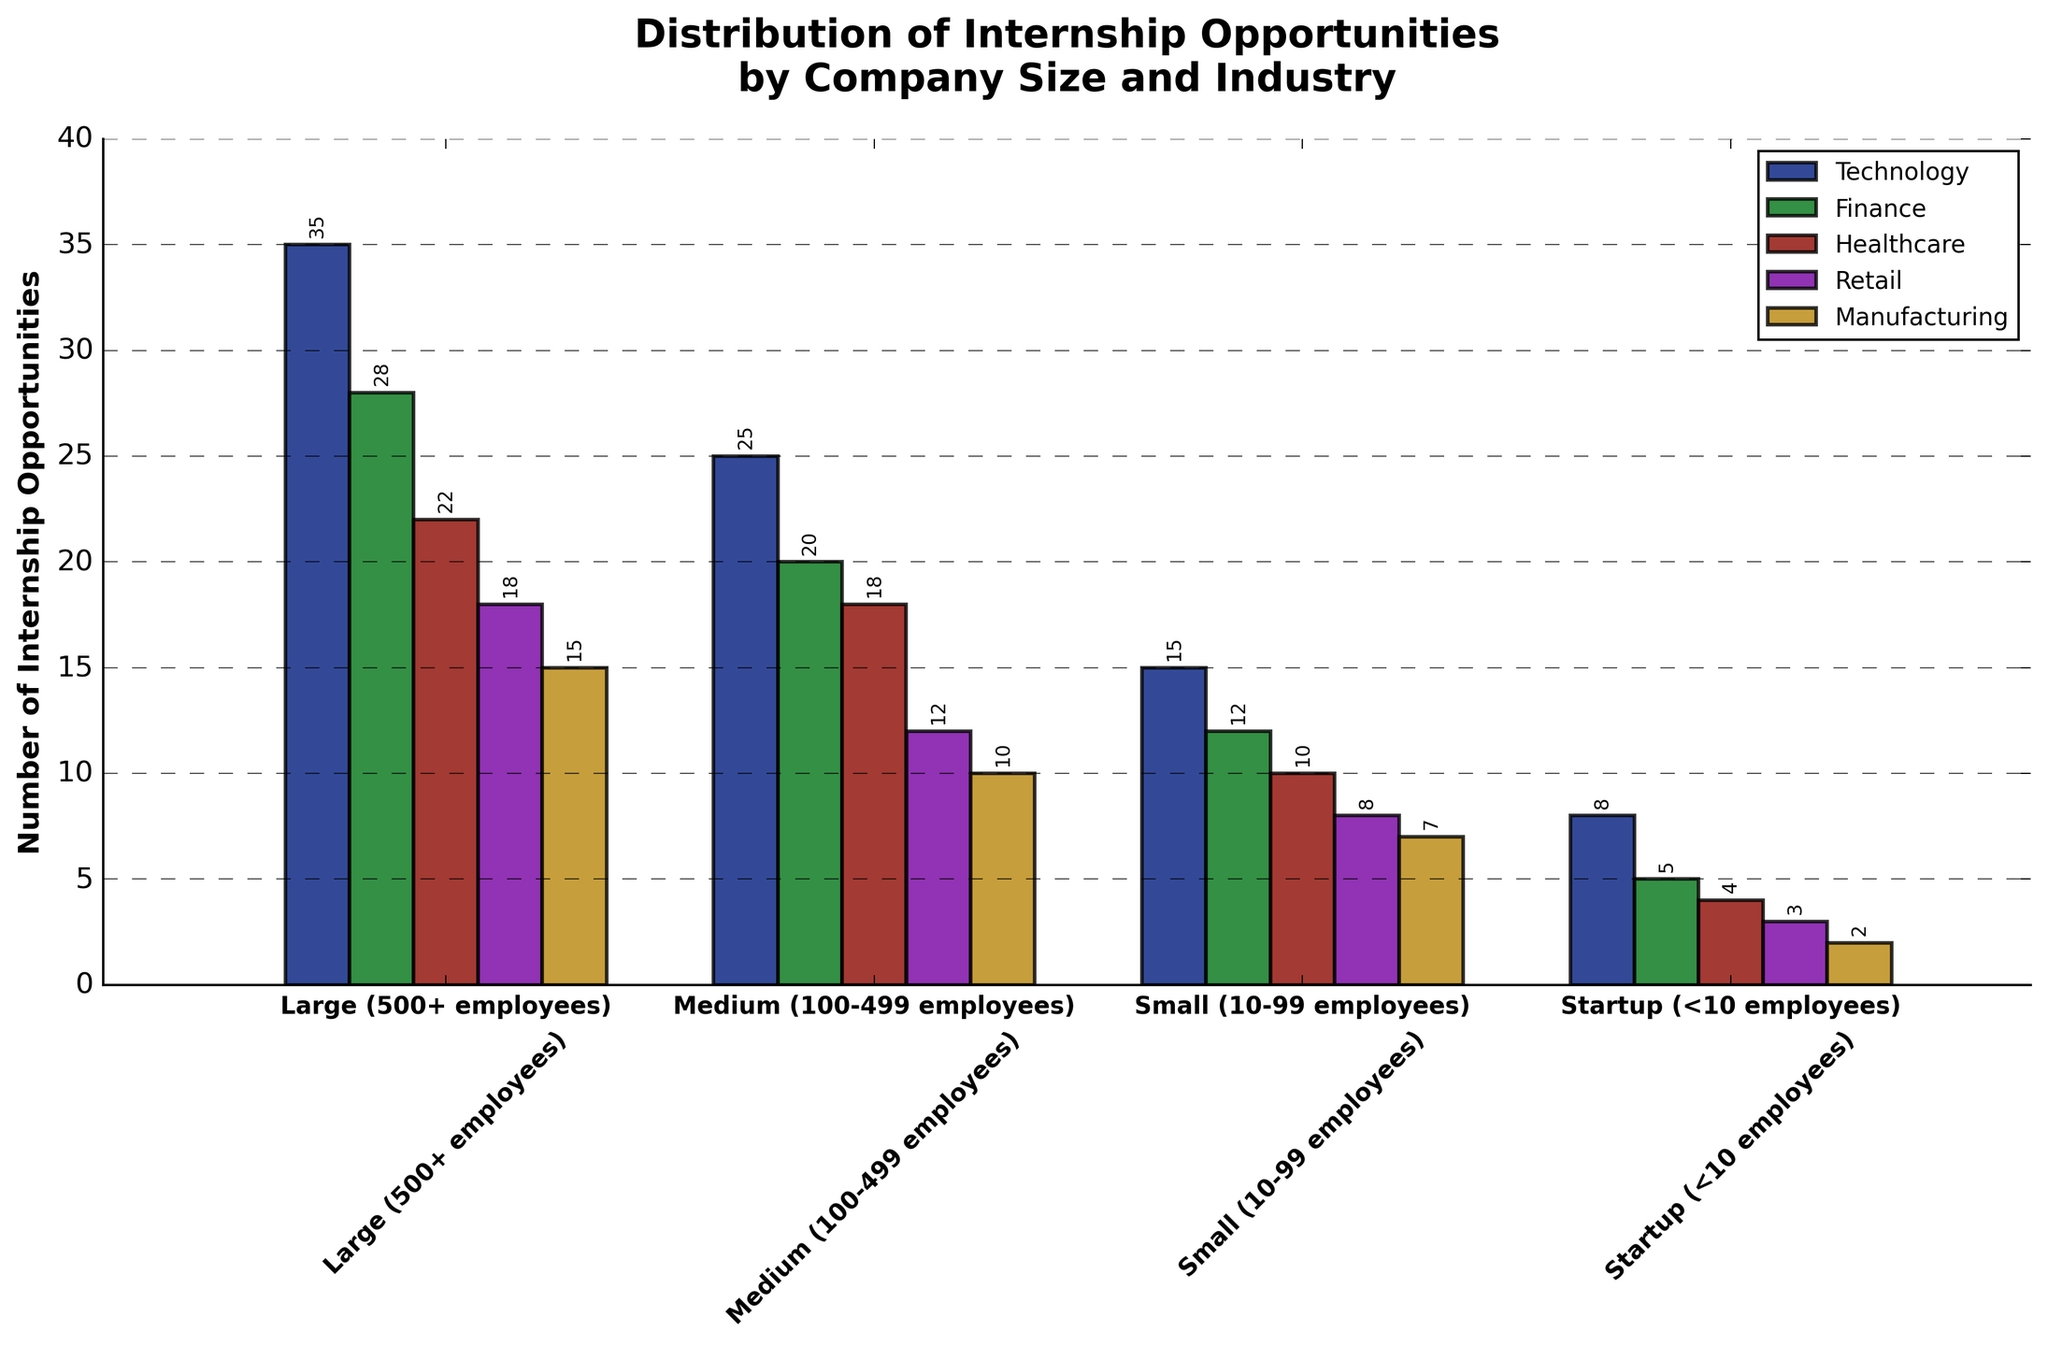Which industry offers the highest number of internship opportunities in large companies? The figure shows a bar chart where the height of each bar represents the number of internship opportunities. The Technology bar for large companies is the tallest, indicating the highest number of opportunities in this sector.
Answer: Technology Compare the number of internship opportunities in Technology and Healthcare for medium companies. Which one is greater? The bars representing medium companies show that the Technology bar is taller than the Healthcare bar. The Technology sector has 25 opportunities, while Healthcare has 18.
Answer: Technology How many total internship opportunities are offered by small companies across all industries? Sum the number of opportunities provided by small companies in each industry: 15 (Technology) + 12 (Finance) + 10 (Healthcare) + 8 (Retail) + 7 (Manufacturing).
Answer: 52 Which company size has the least number of internship opportunities in the Manufacturing sector? The bars for the Manufacturing sector show that the Startup bar is the shortest, indicating the least number of opportunities.
Answer: Startup What is the difference in the number of internship opportunities between large companies and startups in the Finance sector? Subtract the number of opportunities in startups from those in large companies for the Finance sector: 28 (large) - 5 (startup).
Answer: 23 Which two sectors have the same number of internship opportunities in startups? The bars for startups show the heights of the Healthcare and Retail sectors are equal, each offering 4 and 3 opportunities respectively.
Answer: Healthcare and Retail What is the average number of internship opportunities provided by mid-sized companies in the Technology and Retail sectors? Add the number of opportunities in these sectors for medium companies and divide by 2: (25 (Technology) + 12 (Retail)) / 2.
Answer: 18.5 In which industry do medium companies offer more opportunities than large companies? Compare the heights of the bars for medium and large companies in each sector. None of the industries have higher opportunities in medium companies compared to large companies.
Answer: None Which company size contributes the most to the internship opportunities in Retail? The bars for the Retail sector reveal that the largest number of opportunities are offered by large companies, which have the tallest bar.
Answer: Large What is the sum of the internship opportunities across all industries for startups? Calculate the sum of opportunities for each industry provided by startups: 8 (Technology) + 5 (Finance) + 4 (Healthcare) + 3 (Retail) + 2 (Manufacturing).
Answer: 22 